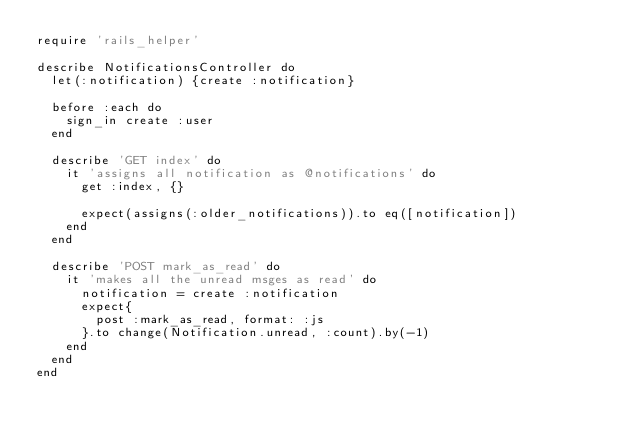<code> <loc_0><loc_0><loc_500><loc_500><_Ruby_>require 'rails_helper'

describe NotificationsController do
  let(:notification) {create :notification}

  before :each do
    sign_in create :user
  end

  describe 'GET index' do
    it 'assigns all notification as @notifications' do
      get :index, {}

      expect(assigns(:older_notifications)).to eq([notification])
    end
  end

  describe 'POST mark_as_read' do
    it 'makes all the unread msges as read' do
      notification = create :notification
      expect{
        post :mark_as_read, format: :js
      }.to change(Notification.unread, :count).by(-1)
    end
  end
end
</code> 